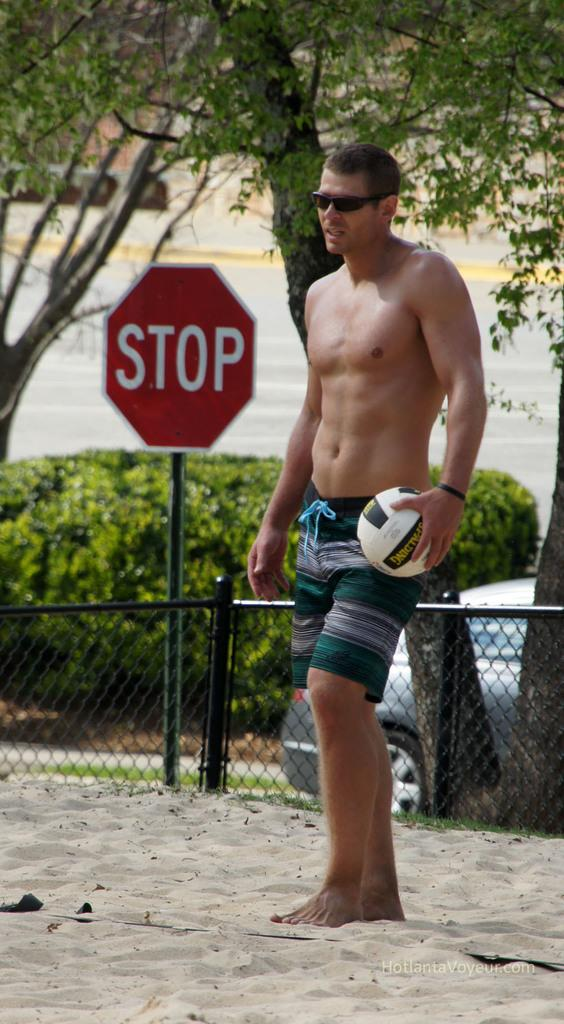What is the main subject of the image? There is a man in the image. What is the man wearing? The man is wearing goggles. What is the man holding? The man is holding a ball. What type of surface is the man standing on? The man is standing on sand. What can be seen in the background of the image? There are railings, a sign board, bushes, and trees in the background of the image. How many brothers does the man have, and what are they doing in the image? There is no information about the man's brothers in the image, nor is there any indication of their presence or activities. What type of vegetable is the man holding in the image? The man is holding a ball, not a vegetable, in the image. 